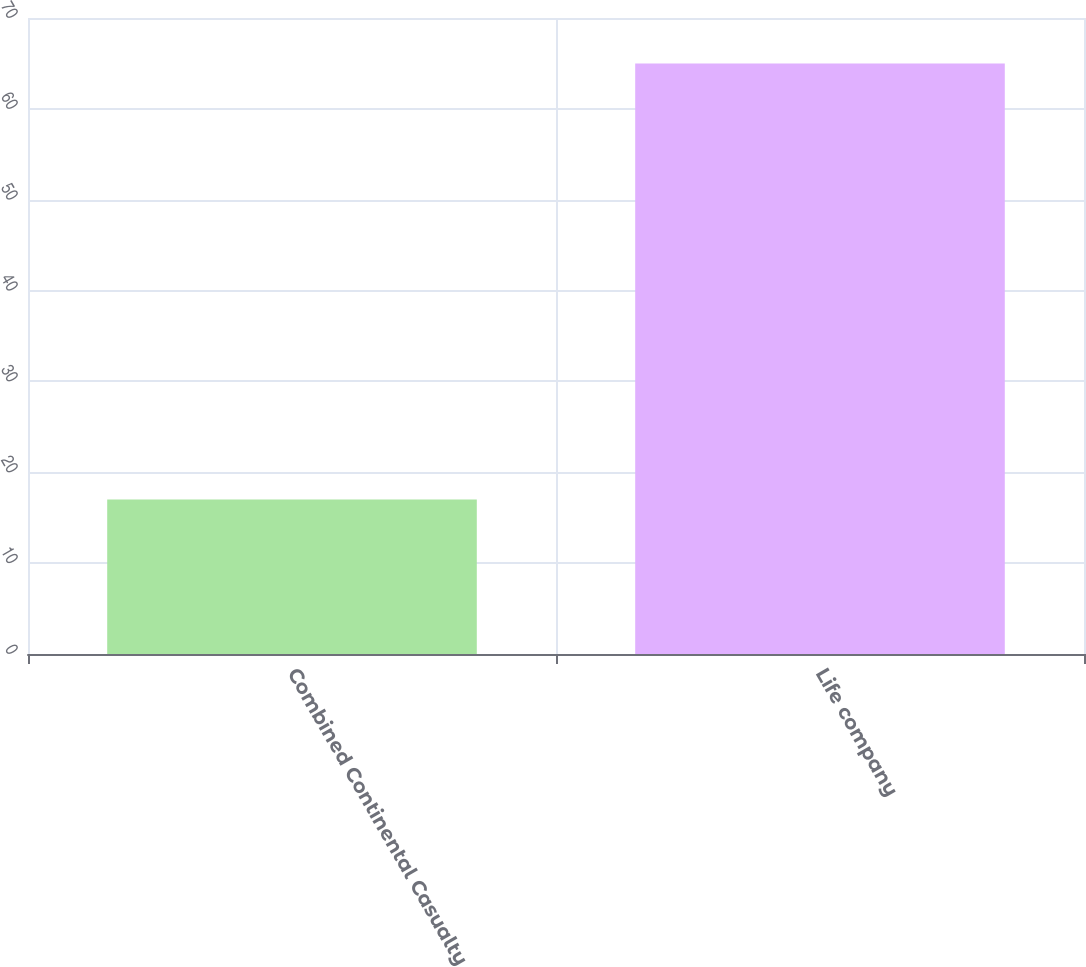<chart> <loc_0><loc_0><loc_500><loc_500><bar_chart><fcel>Combined Continental Casualty<fcel>Life company<nl><fcel>17<fcel>65<nl></chart> 